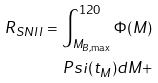<formula> <loc_0><loc_0><loc_500><loc_500>R _ { S N I I } = \int _ { M _ { B , \max } } ^ { 1 2 0 } \Phi ( M ) \\ P s i ( t _ { M } ) d M +</formula> 